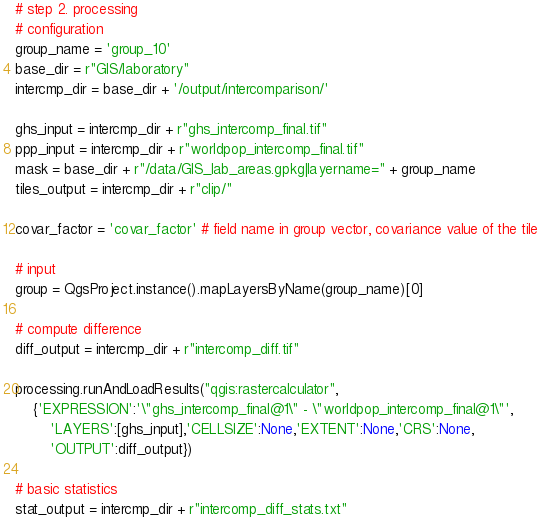<code> <loc_0><loc_0><loc_500><loc_500><_Python_># step 2. processing
# configuration
group_name = 'group_10'
base_dir = r"GIS/laboratory"
intercmp_dir = base_dir + '/output/intercomparison/'

ghs_input = intercmp_dir + r"ghs_intercomp_final.tif"
ppp_input = intercmp_dir + r"worldpop_intercomp_final.tif"
mask = base_dir + r"/data/GIS_lab_areas.gpkg|layername=" + group_name
tiles_output = intercmp_dir + r"clip/"

covar_factor = 'covar_factor' # field name in group vector, covariance value of the tile

# input
group = QgsProject.instance().mapLayersByName(group_name)[0]

# compute difference
diff_output = intercmp_dir + r"intercomp_diff.tif"

processing.runAndLoadResults("qgis:rastercalculator", 
    {'EXPRESSION':'\"ghs_intercomp_final@1\" - \"worldpop_intercomp_final@1\"',
        'LAYERS':[ghs_input],'CELLSIZE':None,'EXTENT':None,'CRS':None,
        'OUTPUT':diff_output})

# basic statistics
stat_output = intercmp_dir + r"intercomp_diff_stats.txt"</code> 